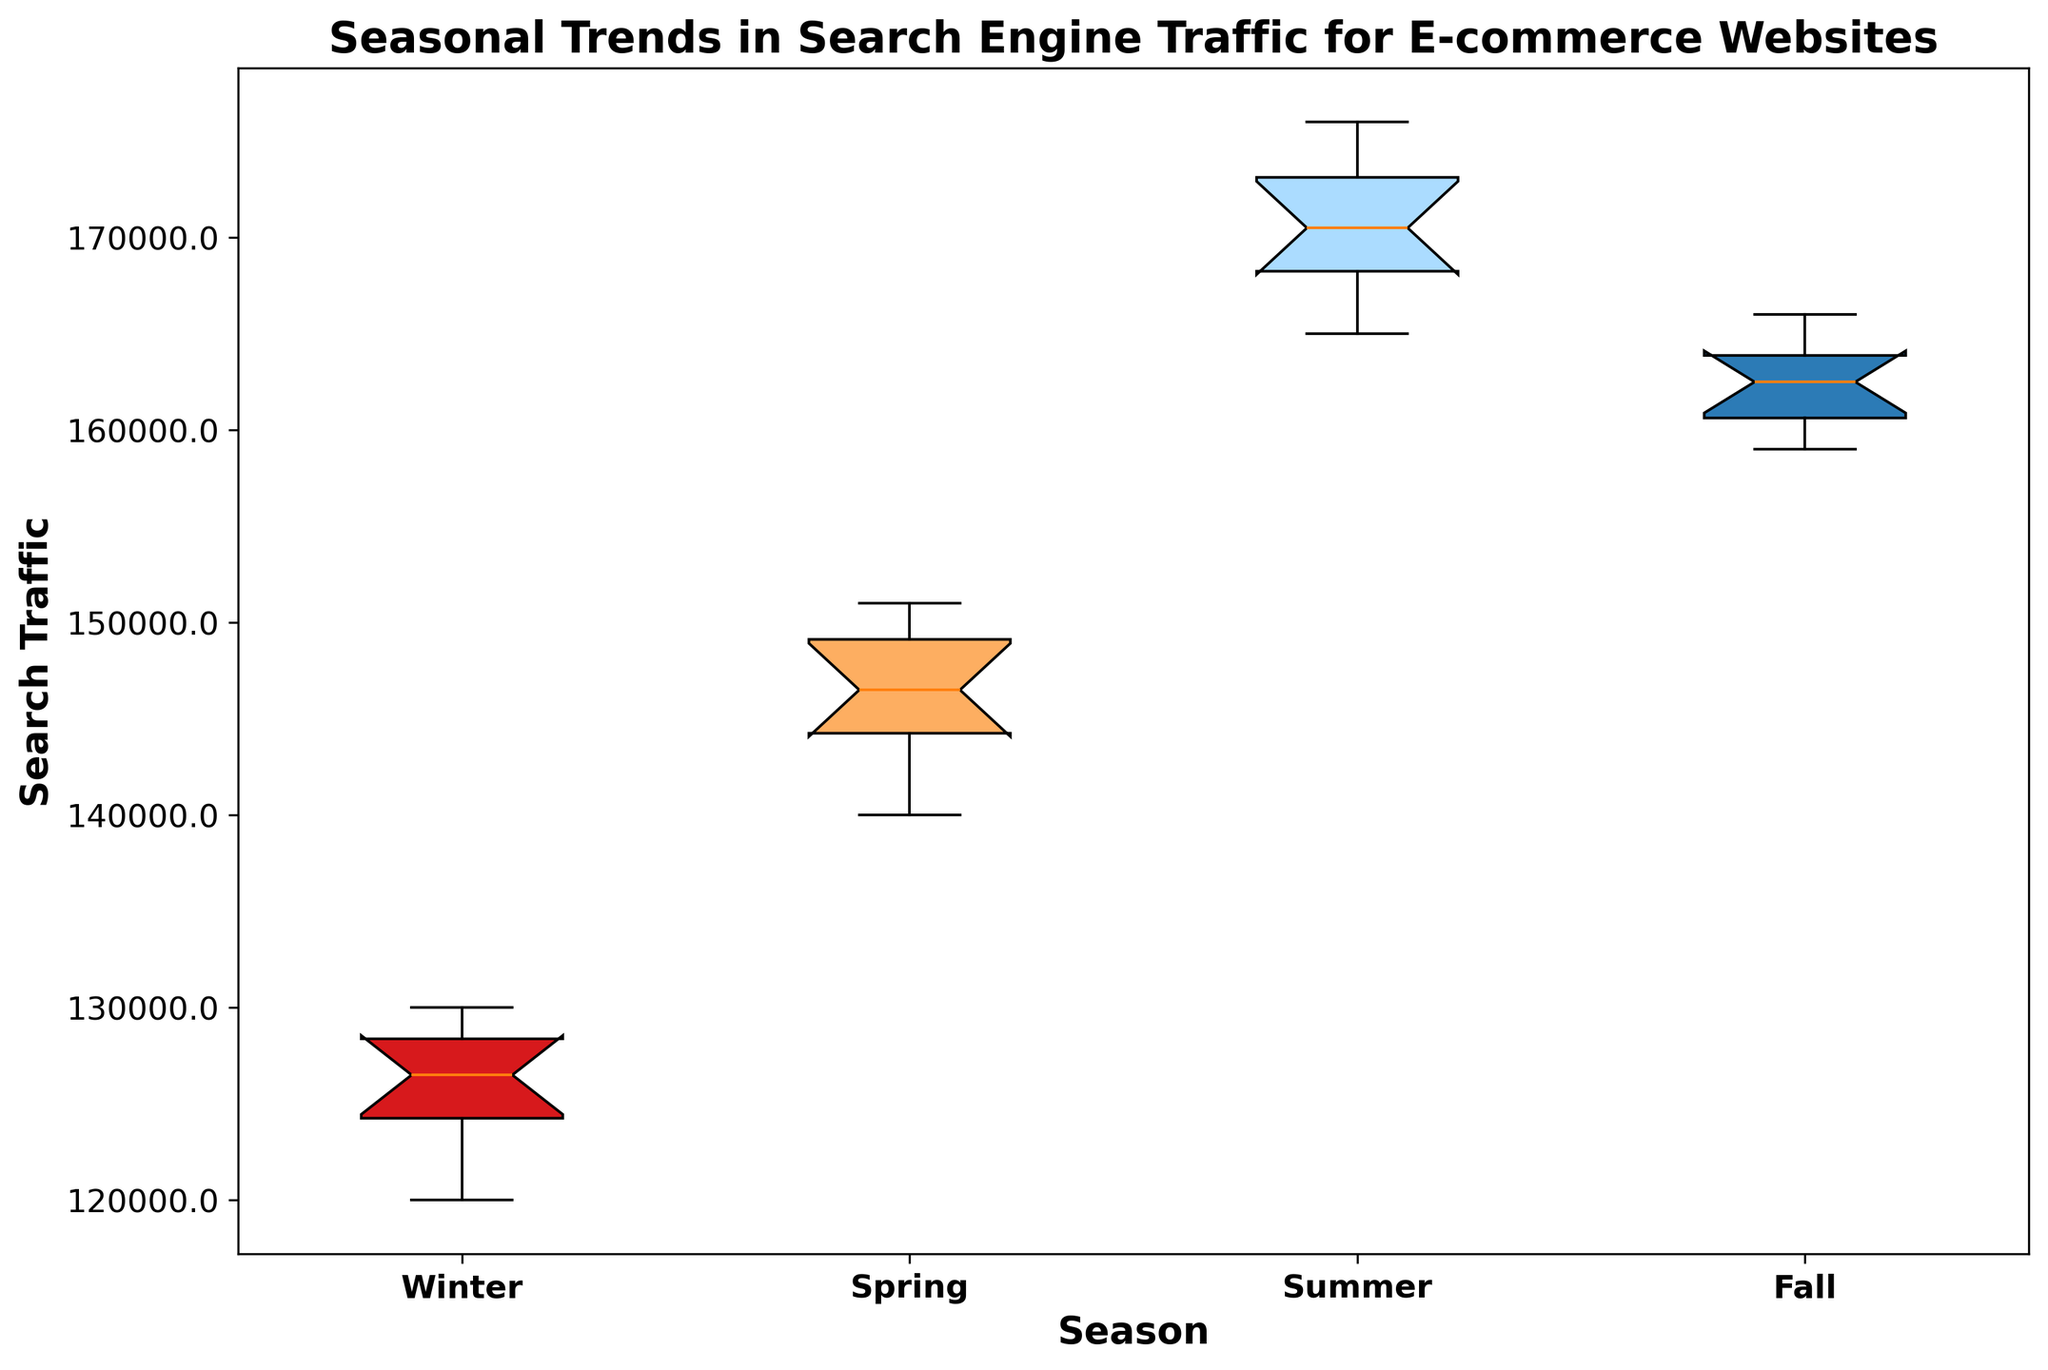Which season has the highest median search traffic? The median value can be identified by looking at the central line within each box in the box plot. The box representing Summer has the highest position among all the boxes, indicating that Summer has the highest median search traffic.
Answer: Summer During which season is the interquartile range (IQR) of search traffic the smallest? The IQR is represented by the height of the box. The smallest box in terms of height represents Spring, indicating the smallest IQR.
Answer: Spring How does the median search traffic in Winter compare to Fall? By comparing the central lines within the boxes for Winter and Fall, it can be seen that the median search traffic for Fall is higher than for Winter.
Answer: Fall is higher Which seasons have overlapping interquartile ranges? To determine overlapping IQRs, look at the boxes in the plot. The IQRs for Spring and Fall overlap, meaning the range between the first and third quartiles for Spring and Fall share some common values.
Answer: Spring and Fall What can you say about the overall range of search traffic in Summer compared to Winter? The overall range, represented by the distance between the top whisker and the bottom whisker, is larger for Summer than Winter, indicating greater variability in Summer's search traffic.
Answer: Larger range in Summer Compare the maximum search traffic value between Summer and Spring. The maximum value is identified by the top whisker. The whisker indicating the maximum is higher for Summer compared to Spring, showing that Summer has a higher maximum search traffic value.
Answer: Summer is higher What is the approximate median search traffic value for Spring? The median value is marked by the central line in the Spring box. By approximating from the y-axis, the median search traffic for Spring is around 146,500.
Answer: Around 146,500 In which season is the spread or variability of search traffic the highest? The spread or variability is indicated by the distance between the lower and upper whiskers. The box plot for Summer has the longest distance between the lower and upper whiskers, indicating the highest variability.
Answer: Summer Which season appears to have the lowest first quartile (Q1) search traffic value? The first quartile is represented by the bottom line of the box. Winter has the lowest bottom line, indicating the lowest Q1 search traffic value.
Answer: Winter What is the color of the box representing Fall? By referring to the visual information in the plot, the box representing Fall is blue.
Answer: Blue 